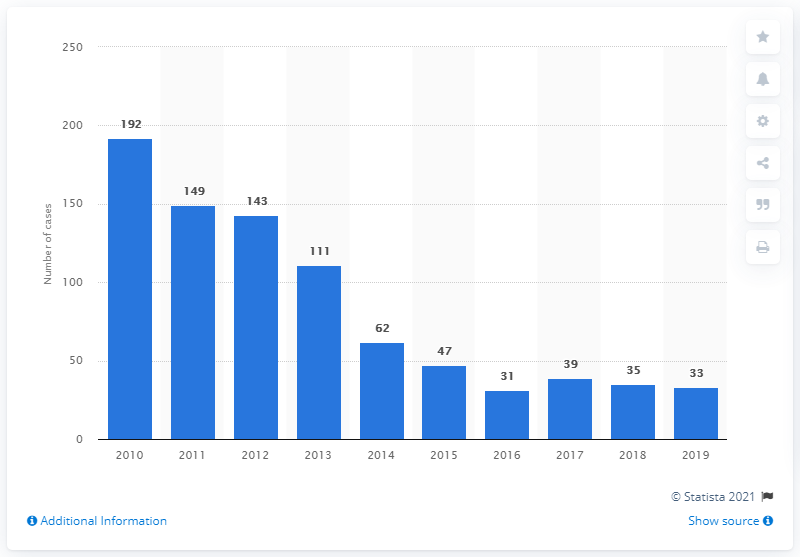Specify some key components in this picture. There were 35 reported cases of malaria in Singapore in the previous year. In 2019, there were 33 reported cases of malaria in Singapore. 